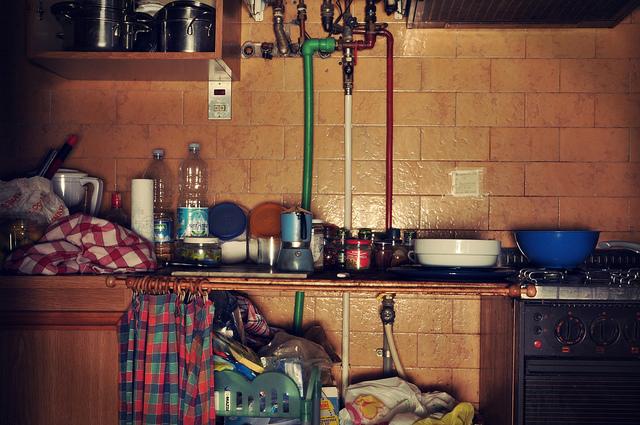What color is the tile on the wall?
Give a very brief answer. Brown. Is the kitchen in this scene Spartan or cluttered?
Quick response, please. Cluttered. IS this photo in high or low contrast lighting?
Keep it brief. Low. 